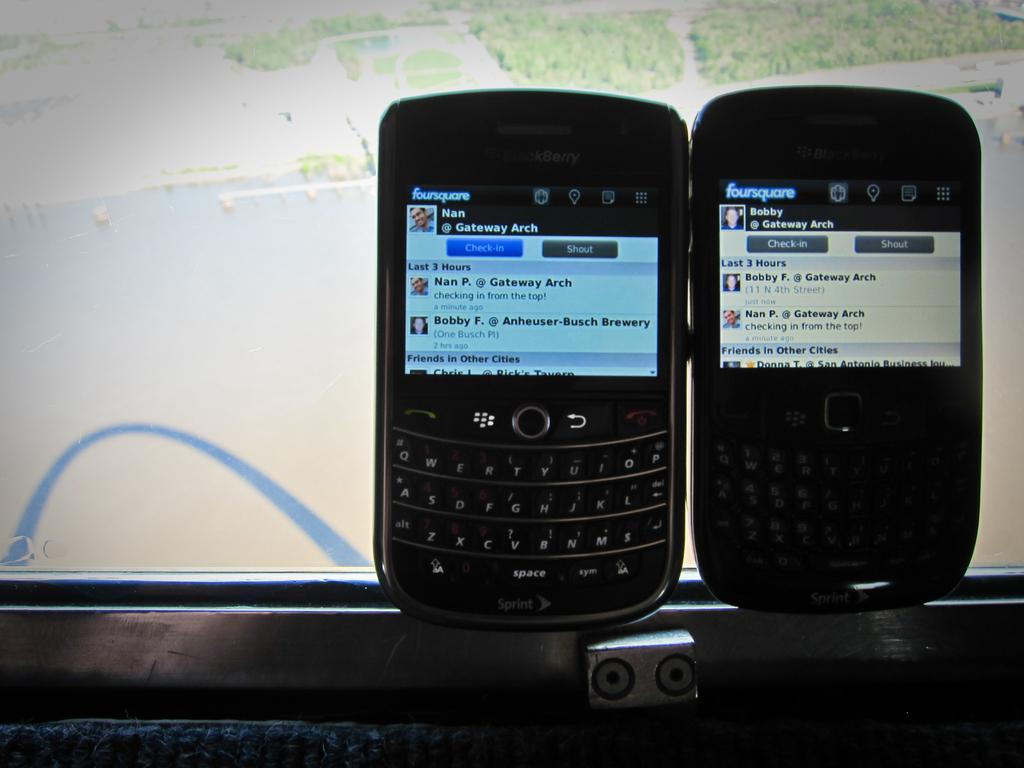<image>
Relay a brief, clear account of the picture shown. Both of the cell phones are displaying screens from Foursquare on them. 